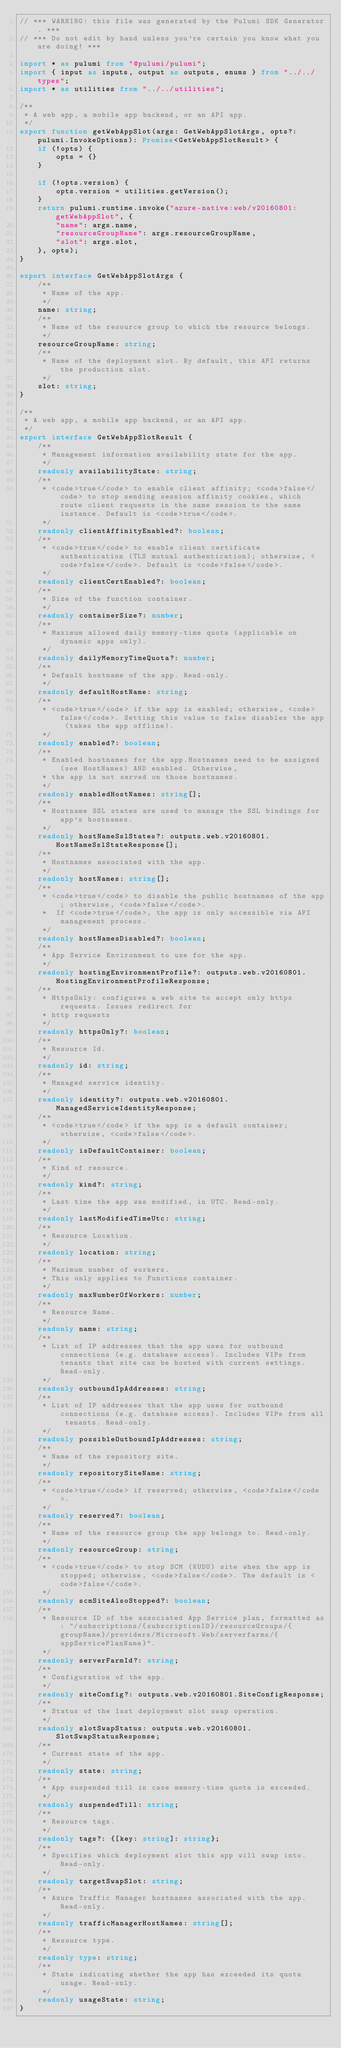Convert code to text. <code><loc_0><loc_0><loc_500><loc_500><_TypeScript_>// *** WARNING: this file was generated by the Pulumi SDK Generator. ***
// *** Do not edit by hand unless you're certain you know what you are doing! ***

import * as pulumi from "@pulumi/pulumi";
import { input as inputs, output as outputs, enums } from "../../types";
import * as utilities from "../../utilities";

/**
 * A web app, a mobile app backend, or an API app.
 */
export function getWebAppSlot(args: GetWebAppSlotArgs, opts?: pulumi.InvokeOptions): Promise<GetWebAppSlotResult> {
    if (!opts) {
        opts = {}
    }

    if (!opts.version) {
        opts.version = utilities.getVersion();
    }
    return pulumi.runtime.invoke("azure-native:web/v20160801:getWebAppSlot", {
        "name": args.name,
        "resourceGroupName": args.resourceGroupName,
        "slot": args.slot,
    }, opts);
}

export interface GetWebAppSlotArgs {
    /**
     * Name of the app.
     */
    name: string;
    /**
     * Name of the resource group to which the resource belongs.
     */
    resourceGroupName: string;
    /**
     * Name of the deployment slot. By default, this API returns the production slot.
     */
    slot: string;
}

/**
 * A web app, a mobile app backend, or an API app.
 */
export interface GetWebAppSlotResult {
    /**
     * Management information availability state for the app.
     */
    readonly availabilityState: string;
    /**
     * <code>true</code> to enable client affinity; <code>false</code> to stop sending session affinity cookies, which route client requests in the same session to the same instance. Default is <code>true</code>.
     */
    readonly clientAffinityEnabled?: boolean;
    /**
     * <code>true</code> to enable client certificate authentication (TLS mutual authentication); otherwise, <code>false</code>. Default is <code>false</code>.
     */
    readonly clientCertEnabled?: boolean;
    /**
     * Size of the function container.
     */
    readonly containerSize?: number;
    /**
     * Maximum allowed daily memory-time quota (applicable on dynamic apps only).
     */
    readonly dailyMemoryTimeQuota?: number;
    /**
     * Default hostname of the app. Read-only.
     */
    readonly defaultHostName: string;
    /**
     * <code>true</code> if the app is enabled; otherwise, <code>false</code>. Setting this value to false disables the app (takes the app offline).
     */
    readonly enabled?: boolean;
    /**
     * Enabled hostnames for the app.Hostnames need to be assigned (see HostNames) AND enabled. Otherwise,
     * the app is not served on those hostnames.
     */
    readonly enabledHostNames: string[];
    /**
     * Hostname SSL states are used to manage the SSL bindings for app's hostnames.
     */
    readonly hostNameSslStates?: outputs.web.v20160801.HostNameSslStateResponse[];
    /**
     * Hostnames associated with the app.
     */
    readonly hostNames: string[];
    /**
     * <code>true</code> to disable the public hostnames of the app; otherwise, <code>false</code>.
     *  If <code>true</code>, the app is only accessible via API management process.
     */
    readonly hostNamesDisabled?: boolean;
    /**
     * App Service Environment to use for the app.
     */
    readonly hostingEnvironmentProfile?: outputs.web.v20160801.HostingEnvironmentProfileResponse;
    /**
     * HttpsOnly: configures a web site to accept only https requests. Issues redirect for
     * http requests
     */
    readonly httpsOnly?: boolean;
    /**
     * Resource Id.
     */
    readonly id: string;
    /**
     * Managed service identity.
     */
    readonly identity?: outputs.web.v20160801.ManagedServiceIdentityResponse;
    /**
     * <code>true</code> if the app is a default container; otherwise, <code>false</code>.
     */
    readonly isDefaultContainer: boolean;
    /**
     * Kind of resource.
     */
    readonly kind?: string;
    /**
     * Last time the app was modified, in UTC. Read-only.
     */
    readonly lastModifiedTimeUtc: string;
    /**
     * Resource Location.
     */
    readonly location: string;
    /**
     * Maximum number of workers.
     * This only applies to Functions container.
     */
    readonly maxNumberOfWorkers: number;
    /**
     * Resource Name.
     */
    readonly name: string;
    /**
     * List of IP addresses that the app uses for outbound connections (e.g. database access). Includes VIPs from tenants that site can be hosted with current settings. Read-only.
     */
    readonly outboundIpAddresses: string;
    /**
     * List of IP addresses that the app uses for outbound connections (e.g. database access). Includes VIPs from all tenants. Read-only.
     */
    readonly possibleOutboundIpAddresses: string;
    /**
     * Name of the repository site.
     */
    readonly repositorySiteName: string;
    /**
     * <code>true</code> if reserved; otherwise, <code>false</code>.
     */
    readonly reserved?: boolean;
    /**
     * Name of the resource group the app belongs to. Read-only.
     */
    readonly resourceGroup: string;
    /**
     * <code>true</code> to stop SCM (KUDU) site when the app is stopped; otherwise, <code>false</code>. The default is <code>false</code>.
     */
    readonly scmSiteAlsoStopped?: boolean;
    /**
     * Resource ID of the associated App Service plan, formatted as: "/subscriptions/{subscriptionID}/resourceGroups/{groupName}/providers/Microsoft.Web/serverfarms/{appServicePlanName}".
     */
    readonly serverFarmId?: string;
    /**
     * Configuration of the app.
     */
    readonly siteConfig?: outputs.web.v20160801.SiteConfigResponse;
    /**
     * Status of the last deployment slot swap operation.
     */
    readonly slotSwapStatus: outputs.web.v20160801.SlotSwapStatusResponse;
    /**
     * Current state of the app.
     */
    readonly state: string;
    /**
     * App suspended till in case memory-time quota is exceeded.
     */
    readonly suspendedTill: string;
    /**
     * Resource tags.
     */
    readonly tags?: {[key: string]: string};
    /**
     * Specifies which deployment slot this app will swap into. Read-only.
     */
    readonly targetSwapSlot: string;
    /**
     * Azure Traffic Manager hostnames associated with the app. Read-only.
     */
    readonly trafficManagerHostNames: string[];
    /**
     * Resource type.
     */
    readonly type: string;
    /**
     * State indicating whether the app has exceeded its quota usage. Read-only.
     */
    readonly usageState: string;
}
</code> 